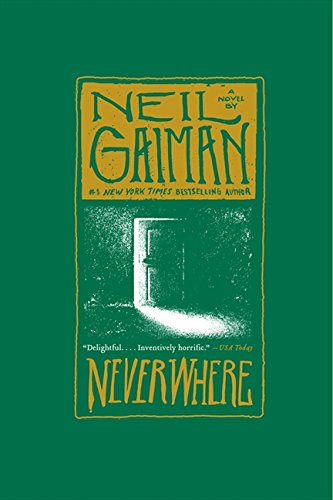What is the title of this book? The title of the book is 'Neverwhere: A Novel', a fascinating journey through a hidden London, filled with adventure and dark fantasy. 